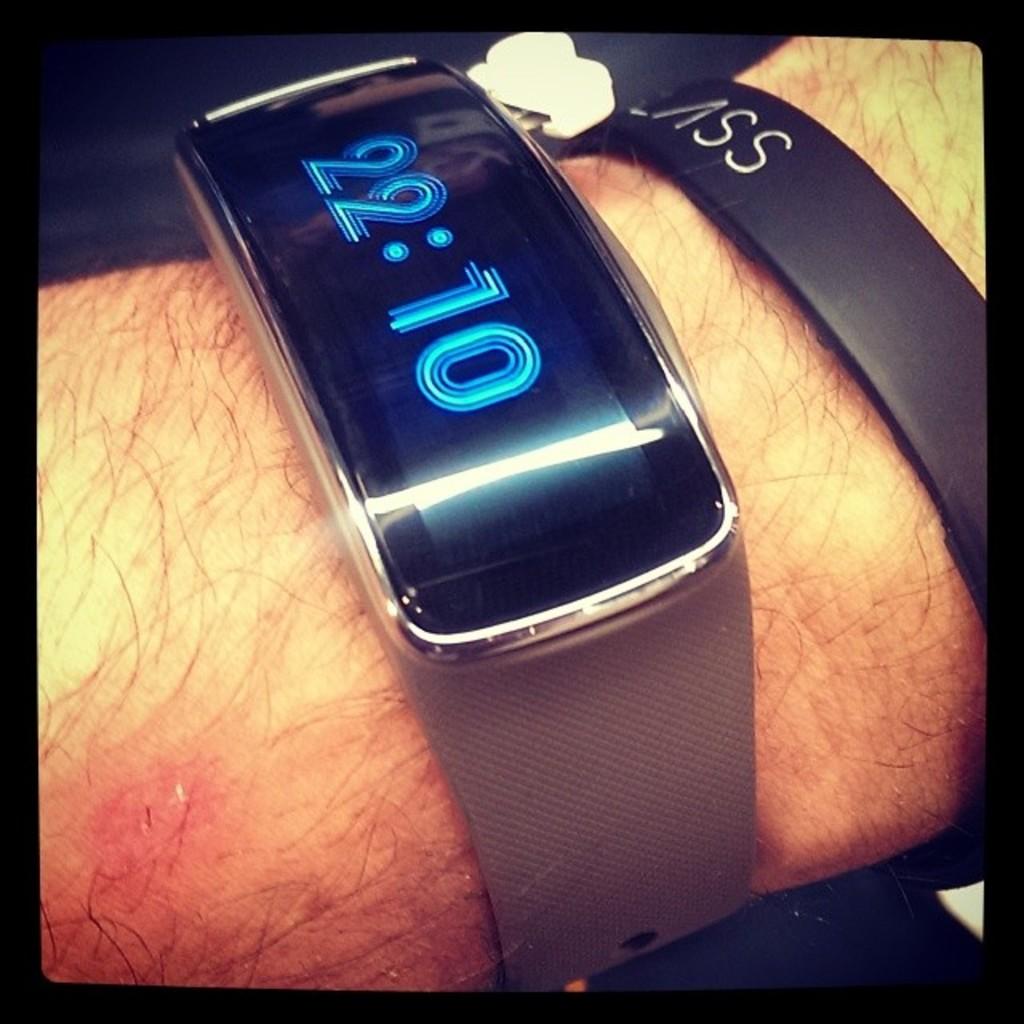What is the time shown?
Your answer should be compact. 22:10. 